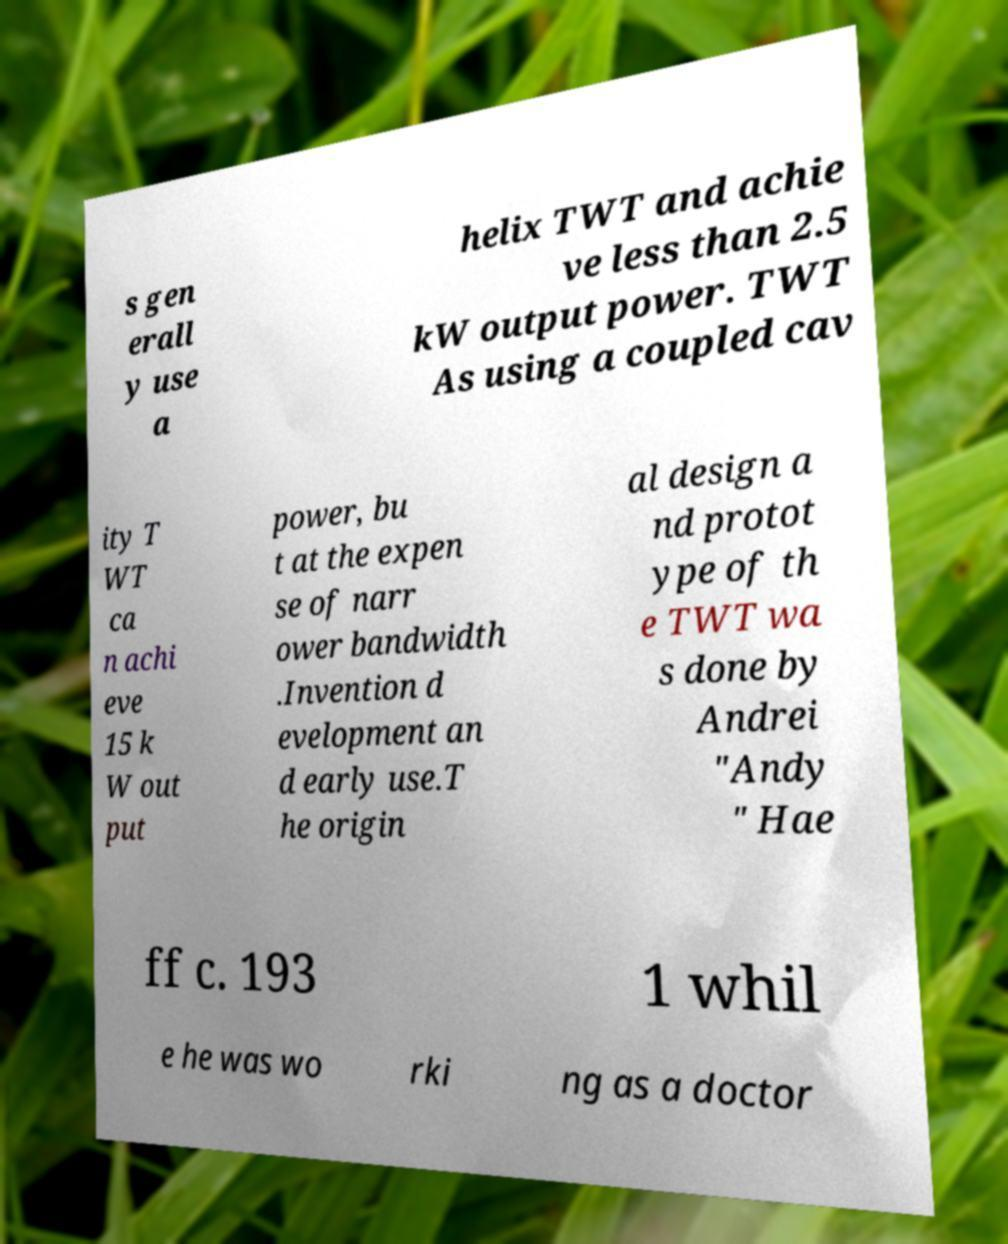For documentation purposes, I need the text within this image transcribed. Could you provide that? s gen erall y use a helix TWT and achie ve less than 2.5 kW output power. TWT As using a coupled cav ity T WT ca n achi eve 15 k W out put power, bu t at the expen se of narr ower bandwidth .Invention d evelopment an d early use.T he origin al design a nd protot ype of th e TWT wa s done by Andrei "Andy " Hae ff c. 193 1 whil e he was wo rki ng as a doctor 